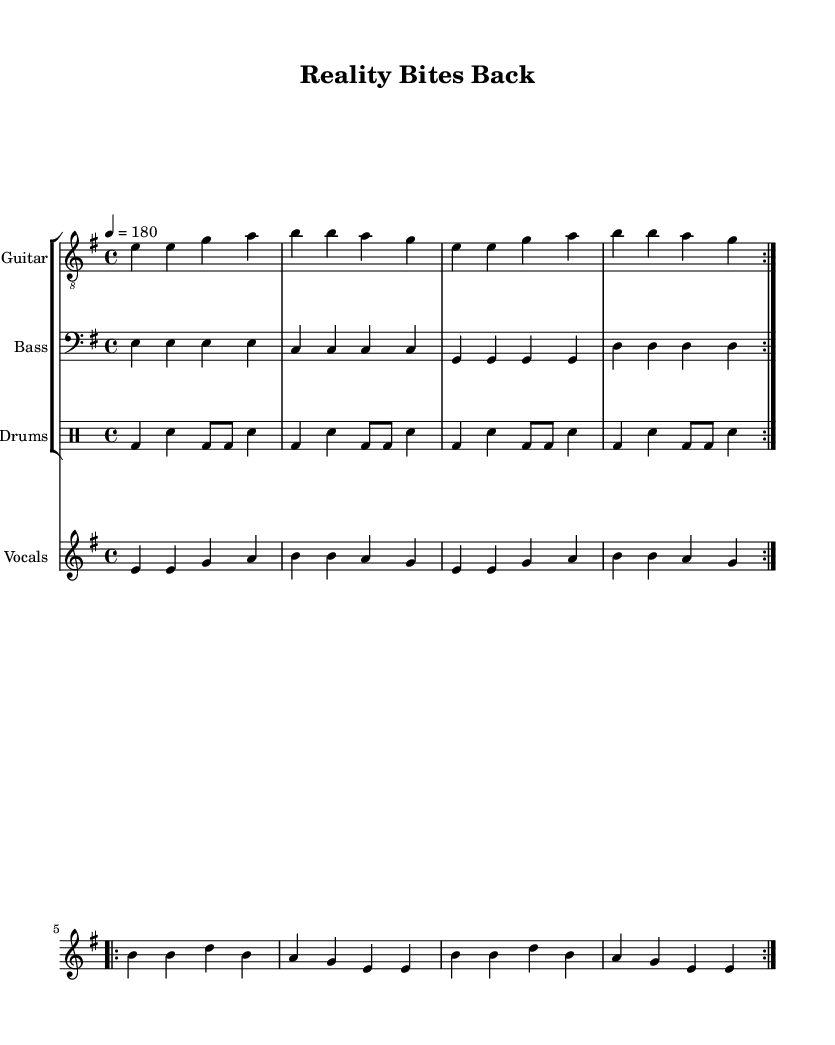What is the key signature of this music? The key signature for this piece is E minor, which is identified by having one sharp, F sharp. This can be seen at the beginning of the sheet music in the key signature indication.
Answer: E minor What is the time signature of this music? The time signature shown at the beginning of the music is 4/4, which means there are four beats per measure and a quarter note receives one beat. This is explicitly stated at the start.
Answer: 4/4 What is the tempo marking for this music? The tempo marking indicates a speed of 180 beats per minute, which is designated at the beginning with "4 = 180". This specifies how fast the piece should be played.
Answer: 180 How many volta sections are repeated in the music? The sheet music indicates that there are 2 volta sections repeated, which is evident by the "repeat volta 2" markings in the guitar and melody sections, signaling that those sections are to be played twice.
Answer: 2 What instrument plays the vocal melody? The vocal melody is specified in the sheet music under the "Vocals" staff. This is labeled clearly in the score, revealing that the melodies are intended for vocal performance.
Answer: Vocals What is the theme addressed by the lyrics of the song? The lyrics reflect a critique of reality television, focusing on themes of superficiality and fakery, explicitly stated in the lines discussing "Cameras rolling, drama unfolds." This indicates a commentary on reality TV culture.
Answer: Reality TV culture What genre does this piece belong to? Based on the structure, themes, and musical elements present in the score, the piece is categorized as Punk music, which typically features fast tempos, strong rhythms, and lyrical critiques of societal issues.
Answer: Punk 